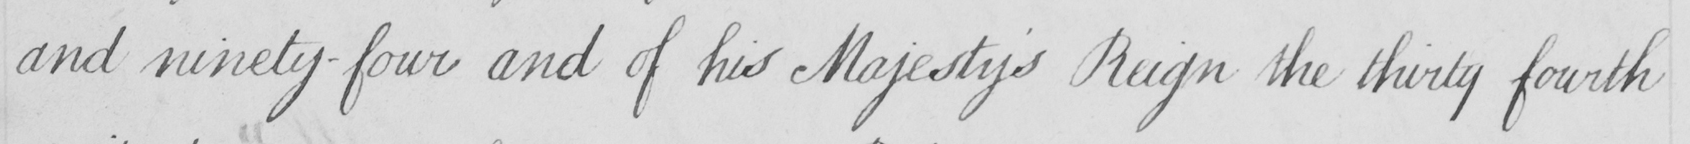Transcribe the text shown in this historical manuscript line. and ninety-four and of his Majesty ' s Reign the thirty fourth 